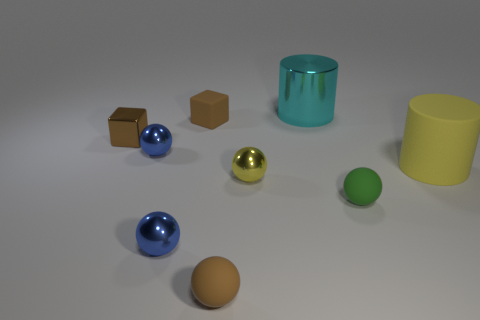There is a yellow object to the right of the small yellow shiny sphere; is there a matte block that is to the left of it?
Make the answer very short. Yes. Are any large blue matte cylinders visible?
Provide a short and direct response. No. How many other shiny objects have the same size as the brown metallic object?
Ensure brevity in your answer.  3. What number of rubber objects are both on the right side of the small yellow sphere and behind the brown metallic thing?
Your answer should be compact. 0. There is a brown cube that is behind the brown metallic thing; is it the same size as the big cyan cylinder?
Your answer should be very brief. No. Are there any other cubes that have the same color as the metal cube?
Provide a succinct answer. Yes. There is a brown block that is made of the same material as the small yellow sphere; what size is it?
Your response must be concise. Small. Are there more objects that are behind the large yellow cylinder than cylinders in front of the metal cylinder?
Make the answer very short. Yes. How many other objects are the same material as the tiny green ball?
Keep it short and to the point. 3. Does the cylinder that is behind the brown shiny thing have the same material as the tiny yellow ball?
Offer a very short reply. Yes. 